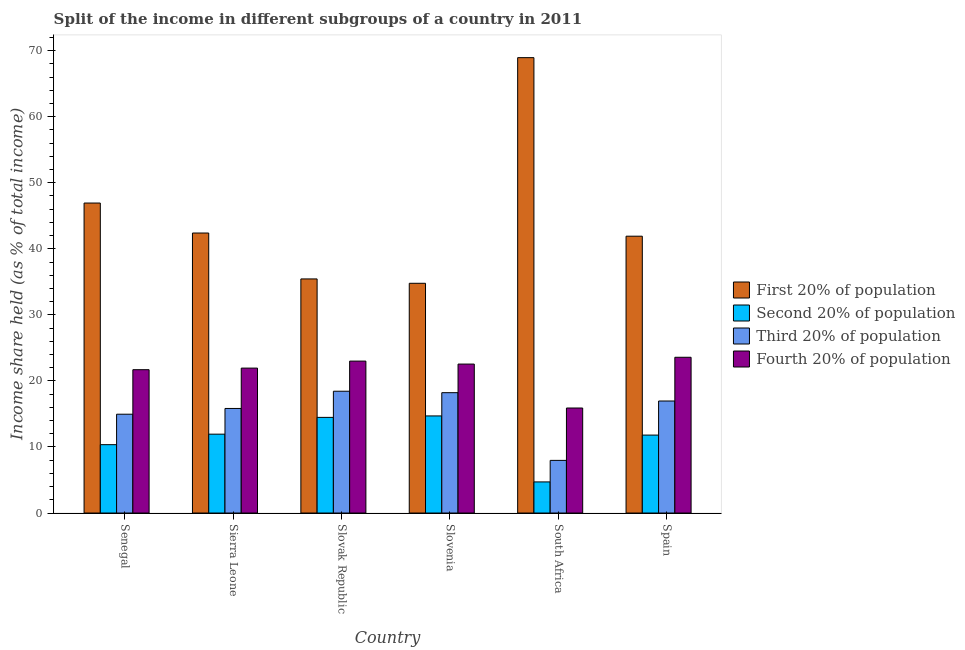How many different coloured bars are there?
Make the answer very short. 4. Are the number of bars per tick equal to the number of legend labels?
Your response must be concise. Yes. How many bars are there on the 3rd tick from the left?
Ensure brevity in your answer.  4. What is the label of the 3rd group of bars from the left?
Provide a succinct answer. Slovak Republic. In how many cases, is the number of bars for a given country not equal to the number of legend labels?
Make the answer very short. 0. What is the share of the income held by third 20% of the population in Senegal?
Your answer should be compact. 14.96. Across all countries, what is the maximum share of the income held by fourth 20% of the population?
Your answer should be very brief. 23.58. Across all countries, what is the minimum share of the income held by second 20% of the population?
Your response must be concise. 4.71. In which country was the share of the income held by second 20% of the population minimum?
Keep it short and to the point. South Africa. What is the total share of the income held by second 20% of the population in the graph?
Provide a short and direct response. 67.98. What is the difference between the share of the income held by first 20% of the population in Senegal and that in Sierra Leone?
Provide a succinct answer. 4.54. What is the difference between the share of the income held by first 20% of the population in Slovak Republic and the share of the income held by fourth 20% of the population in Slovenia?
Your answer should be very brief. 12.89. What is the average share of the income held by first 20% of the population per country?
Your response must be concise. 45.06. What is the difference between the share of the income held by first 20% of the population and share of the income held by fourth 20% of the population in Slovenia?
Provide a short and direct response. 12.23. What is the ratio of the share of the income held by fourth 20% of the population in Senegal to that in Slovenia?
Your answer should be very brief. 0.96. Is the share of the income held by first 20% of the population in Senegal less than that in Spain?
Make the answer very short. No. Is the difference between the share of the income held by second 20% of the population in Senegal and South Africa greater than the difference between the share of the income held by first 20% of the population in Senegal and South Africa?
Ensure brevity in your answer.  Yes. What is the difference between the highest and the second highest share of the income held by second 20% of the population?
Provide a succinct answer. 0.22. What is the difference between the highest and the lowest share of the income held by fourth 20% of the population?
Your response must be concise. 7.68. Is it the case that in every country, the sum of the share of the income held by third 20% of the population and share of the income held by second 20% of the population is greater than the sum of share of the income held by fourth 20% of the population and share of the income held by first 20% of the population?
Offer a terse response. No. What does the 4th bar from the left in Spain represents?
Your answer should be very brief. Fourth 20% of population. What does the 2nd bar from the right in Slovak Republic represents?
Keep it short and to the point. Third 20% of population. Is it the case that in every country, the sum of the share of the income held by first 20% of the population and share of the income held by second 20% of the population is greater than the share of the income held by third 20% of the population?
Ensure brevity in your answer.  Yes. What is the difference between two consecutive major ticks on the Y-axis?
Offer a very short reply. 10. Are the values on the major ticks of Y-axis written in scientific E-notation?
Keep it short and to the point. No. Does the graph contain any zero values?
Offer a very short reply. No. Does the graph contain grids?
Your response must be concise. No. Where does the legend appear in the graph?
Provide a succinct answer. Center right. How are the legend labels stacked?
Your answer should be very brief. Vertical. What is the title of the graph?
Make the answer very short. Split of the income in different subgroups of a country in 2011. Does "Sweden" appear as one of the legend labels in the graph?
Keep it short and to the point. No. What is the label or title of the X-axis?
Your answer should be very brief. Country. What is the label or title of the Y-axis?
Make the answer very short. Income share held (as % of total income). What is the Income share held (as % of total income) of First 20% of population in Senegal?
Offer a terse response. 46.93. What is the Income share held (as % of total income) of Second 20% of population in Senegal?
Offer a very short reply. 10.35. What is the Income share held (as % of total income) of Third 20% of population in Senegal?
Make the answer very short. 14.96. What is the Income share held (as % of total income) of Fourth 20% of population in Senegal?
Ensure brevity in your answer.  21.7. What is the Income share held (as % of total income) of First 20% of population in Sierra Leone?
Your response must be concise. 42.39. What is the Income share held (as % of total income) in Second 20% of population in Sierra Leone?
Give a very brief answer. 11.94. What is the Income share held (as % of total income) in Third 20% of population in Sierra Leone?
Your response must be concise. 15.83. What is the Income share held (as % of total income) of Fourth 20% of population in Sierra Leone?
Your answer should be very brief. 21.94. What is the Income share held (as % of total income) in First 20% of population in Slovak Republic?
Offer a very short reply. 35.44. What is the Income share held (as % of total income) in Second 20% of population in Slovak Republic?
Ensure brevity in your answer.  14.48. What is the Income share held (as % of total income) in Third 20% of population in Slovak Republic?
Your response must be concise. 18.44. What is the Income share held (as % of total income) of First 20% of population in Slovenia?
Offer a terse response. 34.78. What is the Income share held (as % of total income) in Second 20% of population in Slovenia?
Your answer should be very brief. 14.7. What is the Income share held (as % of total income) in Third 20% of population in Slovenia?
Your answer should be compact. 18.22. What is the Income share held (as % of total income) of Fourth 20% of population in Slovenia?
Keep it short and to the point. 22.55. What is the Income share held (as % of total income) of First 20% of population in South Africa?
Give a very brief answer. 68.94. What is the Income share held (as % of total income) of Second 20% of population in South Africa?
Provide a succinct answer. 4.71. What is the Income share held (as % of total income) of Third 20% of population in South Africa?
Give a very brief answer. 7.97. What is the Income share held (as % of total income) in Fourth 20% of population in South Africa?
Ensure brevity in your answer.  15.9. What is the Income share held (as % of total income) in First 20% of population in Spain?
Your answer should be very brief. 41.91. What is the Income share held (as % of total income) of Second 20% of population in Spain?
Offer a terse response. 11.8. What is the Income share held (as % of total income) of Third 20% of population in Spain?
Ensure brevity in your answer.  16.96. What is the Income share held (as % of total income) of Fourth 20% of population in Spain?
Your answer should be compact. 23.58. Across all countries, what is the maximum Income share held (as % of total income) of First 20% of population?
Provide a short and direct response. 68.94. Across all countries, what is the maximum Income share held (as % of total income) of Third 20% of population?
Provide a succinct answer. 18.44. Across all countries, what is the maximum Income share held (as % of total income) of Fourth 20% of population?
Make the answer very short. 23.58. Across all countries, what is the minimum Income share held (as % of total income) of First 20% of population?
Make the answer very short. 34.78. Across all countries, what is the minimum Income share held (as % of total income) in Second 20% of population?
Make the answer very short. 4.71. Across all countries, what is the minimum Income share held (as % of total income) in Third 20% of population?
Offer a very short reply. 7.97. Across all countries, what is the minimum Income share held (as % of total income) in Fourth 20% of population?
Provide a succinct answer. 15.9. What is the total Income share held (as % of total income) in First 20% of population in the graph?
Offer a very short reply. 270.39. What is the total Income share held (as % of total income) of Second 20% of population in the graph?
Offer a very short reply. 67.98. What is the total Income share held (as % of total income) in Third 20% of population in the graph?
Keep it short and to the point. 92.38. What is the total Income share held (as % of total income) in Fourth 20% of population in the graph?
Ensure brevity in your answer.  128.67. What is the difference between the Income share held (as % of total income) of First 20% of population in Senegal and that in Sierra Leone?
Give a very brief answer. 4.54. What is the difference between the Income share held (as % of total income) of Second 20% of population in Senegal and that in Sierra Leone?
Your answer should be very brief. -1.59. What is the difference between the Income share held (as % of total income) of Third 20% of population in Senegal and that in Sierra Leone?
Give a very brief answer. -0.87. What is the difference between the Income share held (as % of total income) in Fourth 20% of population in Senegal and that in Sierra Leone?
Provide a succinct answer. -0.24. What is the difference between the Income share held (as % of total income) in First 20% of population in Senegal and that in Slovak Republic?
Make the answer very short. 11.49. What is the difference between the Income share held (as % of total income) in Second 20% of population in Senegal and that in Slovak Republic?
Give a very brief answer. -4.13. What is the difference between the Income share held (as % of total income) in Third 20% of population in Senegal and that in Slovak Republic?
Your answer should be very brief. -3.48. What is the difference between the Income share held (as % of total income) in First 20% of population in Senegal and that in Slovenia?
Your answer should be very brief. 12.15. What is the difference between the Income share held (as % of total income) in Second 20% of population in Senegal and that in Slovenia?
Your answer should be very brief. -4.35. What is the difference between the Income share held (as % of total income) in Third 20% of population in Senegal and that in Slovenia?
Your answer should be compact. -3.26. What is the difference between the Income share held (as % of total income) of Fourth 20% of population in Senegal and that in Slovenia?
Provide a short and direct response. -0.85. What is the difference between the Income share held (as % of total income) of First 20% of population in Senegal and that in South Africa?
Your answer should be very brief. -22.01. What is the difference between the Income share held (as % of total income) of Second 20% of population in Senegal and that in South Africa?
Offer a very short reply. 5.64. What is the difference between the Income share held (as % of total income) in Third 20% of population in Senegal and that in South Africa?
Offer a terse response. 6.99. What is the difference between the Income share held (as % of total income) of First 20% of population in Senegal and that in Spain?
Your answer should be very brief. 5.02. What is the difference between the Income share held (as % of total income) of Second 20% of population in Senegal and that in Spain?
Your answer should be very brief. -1.45. What is the difference between the Income share held (as % of total income) in Fourth 20% of population in Senegal and that in Spain?
Ensure brevity in your answer.  -1.88. What is the difference between the Income share held (as % of total income) of First 20% of population in Sierra Leone and that in Slovak Republic?
Make the answer very short. 6.95. What is the difference between the Income share held (as % of total income) in Second 20% of population in Sierra Leone and that in Slovak Republic?
Your response must be concise. -2.54. What is the difference between the Income share held (as % of total income) in Third 20% of population in Sierra Leone and that in Slovak Republic?
Ensure brevity in your answer.  -2.61. What is the difference between the Income share held (as % of total income) of Fourth 20% of population in Sierra Leone and that in Slovak Republic?
Provide a short and direct response. -1.06. What is the difference between the Income share held (as % of total income) of First 20% of population in Sierra Leone and that in Slovenia?
Give a very brief answer. 7.61. What is the difference between the Income share held (as % of total income) of Second 20% of population in Sierra Leone and that in Slovenia?
Provide a short and direct response. -2.76. What is the difference between the Income share held (as % of total income) in Third 20% of population in Sierra Leone and that in Slovenia?
Offer a terse response. -2.39. What is the difference between the Income share held (as % of total income) in Fourth 20% of population in Sierra Leone and that in Slovenia?
Your answer should be compact. -0.61. What is the difference between the Income share held (as % of total income) in First 20% of population in Sierra Leone and that in South Africa?
Keep it short and to the point. -26.55. What is the difference between the Income share held (as % of total income) of Second 20% of population in Sierra Leone and that in South Africa?
Your answer should be compact. 7.23. What is the difference between the Income share held (as % of total income) in Third 20% of population in Sierra Leone and that in South Africa?
Give a very brief answer. 7.86. What is the difference between the Income share held (as % of total income) in Fourth 20% of population in Sierra Leone and that in South Africa?
Your response must be concise. 6.04. What is the difference between the Income share held (as % of total income) in First 20% of population in Sierra Leone and that in Spain?
Your response must be concise. 0.48. What is the difference between the Income share held (as % of total income) of Second 20% of population in Sierra Leone and that in Spain?
Offer a terse response. 0.14. What is the difference between the Income share held (as % of total income) in Third 20% of population in Sierra Leone and that in Spain?
Provide a short and direct response. -1.13. What is the difference between the Income share held (as % of total income) of Fourth 20% of population in Sierra Leone and that in Spain?
Offer a very short reply. -1.64. What is the difference between the Income share held (as % of total income) of First 20% of population in Slovak Republic and that in Slovenia?
Your answer should be compact. 0.66. What is the difference between the Income share held (as % of total income) of Second 20% of population in Slovak Republic and that in Slovenia?
Keep it short and to the point. -0.22. What is the difference between the Income share held (as % of total income) of Third 20% of population in Slovak Republic and that in Slovenia?
Provide a succinct answer. 0.22. What is the difference between the Income share held (as % of total income) of Fourth 20% of population in Slovak Republic and that in Slovenia?
Your response must be concise. 0.45. What is the difference between the Income share held (as % of total income) of First 20% of population in Slovak Republic and that in South Africa?
Keep it short and to the point. -33.5. What is the difference between the Income share held (as % of total income) in Second 20% of population in Slovak Republic and that in South Africa?
Provide a succinct answer. 9.77. What is the difference between the Income share held (as % of total income) in Third 20% of population in Slovak Republic and that in South Africa?
Provide a short and direct response. 10.47. What is the difference between the Income share held (as % of total income) in First 20% of population in Slovak Republic and that in Spain?
Your answer should be compact. -6.47. What is the difference between the Income share held (as % of total income) of Second 20% of population in Slovak Republic and that in Spain?
Provide a short and direct response. 2.68. What is the difference between the Income share held (as % of total income) in Third 20% of population in Slovak Republic and that in Spain?
Your answer should be compact. 1.48. What is the difference between the Income share held (as % of total income) of Fourth 20% of population in Slovak Republic and that in Spain?
Make the answer very short. -0.58. What is the difference between the Income share held (as % of total income) of First 20% of population in Slovenia and that in South Africa?
Ensure brevity in your answer.  -34.16. What is the difference between the Income share held (as % of total income) in Second 20% of population in Slovenia and that in South Africa?
Your answer should be very brief. 9.99. What is the difference between the Income share held (as % of total income) in Third 20% of population in Slovenia and that in South Africa?
Offer a terse response. 10.25. What is the difference between the Income share held (as % of total income) of Fourth 20% of population in Slovenia and that in South Africa?
Your answer should be very brief. 6.65. What is the difference between the Income share held (as % of total income) of First 20% of population in Slovenia and that in Spain?
Provide a succinct answer. -7.13. What is the difference between the Income share held (as % of total income) in Second 20% of population in Slovenia and that in Spain?
Keep it short and to the point. 2.9. What is the difference between the Income share held (as % of total income) in Third 20% of population in Slovenia and that in Spain?
Provide a succinct answer. 1.26. What is the difference between the Income share held (as % of total income) in Fourth 20% of population in Slovenia and that in Spain?
Your response must be concise. -1.03. What is the difference between the Income share held (as % of total income) of First 20% of population in South Africa and that in Spain?
Give a very brief answer. 27.03. What is the difference between the Income share held (as % of total income) of Second 20% of population in South Africa and that in Spain?
Your answer should be very brief. -7.09. What is the difference between the Income share held (as % of total income) in Third 20% of population in South Africa and that in Spain?
Ensure brevity in your answer.  -8.99. What is the difference between the Income share held (as % of total income) of Fourth 20% of population in South Africa and that in Spain?
Your response must be concise. -7.68. What is the difference between the Income share held (as % of total income) of First 20% of population in Senegal and the Income share held (as % of total income) of Second 20% of population in Sierra Leone?
Keep it short and to the point. 34.99. What is the difference between the Income share held (as % of total income) of First 20% of population in Senegal and the Income share held (as % of total income) of Third 20% of population in Sierra Leone?
Provide a short and direct response. 31.1. What is the difference between the Income share held (as % of total income) in First 20% of population in Senegal and the Income share held (as % of total income) in Fourth 20% of population in Sierra Leone?
Your answer should be very brief. 24.99. What is the difference between the Income share held (as % of total income) of Second 20% of population in Senegal and the Income share held (as % of total income) of Third 20% of population in Sierra Leone?
Offer a very short reply. -5.48. What is the difference between the Income share held (as % of total income) in Second 20% of population in Senegal and the Income share held (as % of total income) in Fourth 20% of population in Sierra Leone?
Your answer should be compact. -11.59. What is the difference between the Income share held (as % of total income) in Third 20% of population in Senegal and the Income share held (as % of total income) in Fourth 20% of population in Sierra Leone?
Give a very brief answer. -6.98. What is the difference between the Income share held (as % of total income) in First 20% of population in Senegal and the Income share held (as % of total income) in Second 20% of population in Slovak Republic?
Provide a succinct answer. 32.45. What is the difference between the Income share held (as % of total income) of First 20% of population in Senegal and the Income share held (as % of total income) of Third 20% of population in Slovak Republic?
Your answer should be very brief. 28.49. What is the difference between the Income share held (as % of total income) of First 20% of population in Senegal and the Income share held (as % of total income) of Fourth 20% of population in Slovak Republic?
Your answer should be very brief. 23.93. What is the difference between the Income share held (as % of total income) in Second 20% of population in Senegal and the Income share held (as % of total income) in Third 20% of population in Slovak Republic?
Your answer should be compact. -8.09. What is the difference between the Income share held (as % of total income) in Second 20% of population in Senegal and the Income share held (as % of total income) in Fourth 20% of population in Slovak Republic?
Offer a very short reply. -12.65. What is the difference between the Income share held (as % of total income) of Third 20% of population in Senegal and the Income share held (as % of total income) of Fourth 20% of population in Slovak Republic?
Your response must be concise. -8.04. What is the difference between the Income share held (as % of total income) of First 20% of population in Senegal and the Income share held (as % of total income) of Second 20% of population in Slovenia?
Your answer should be compact. 32.23. What is the difference between the Income share held (as % of total income) of First 20% of population in Senegal and the Income share held (as % of total income) of Third 20% of population in Slovenia?
Ensure brevity in your answer.  28.71. What is the difference between the Income share held (as % of total income) in First 20% of population in Senegal and the Income share held (as % of total income) in Fourth 20% of population in Slovenia?
Keep it short and to the point. 24.38. What is the difference between the Income share held (as % of total income) in Second 20% of population in Senegal and the Income share held (as % of total income) in Third 20% of population in Slovenia?
Your answer should be compact. -7.87. What is the difference between the Income share held (as % of total income) of Third 20% of population in Senegal and the Income share held (as % of total income) of Fourth 20% of population in Slovenia?
Keep it short and to the point. -7.59. What is the difference between the Income share held (as % of total income) of First 20% of population in Senegal and the Income share held (as % of total income) of Second 20% of population in South Africa?
Ensure brevity in your answer.  42.22. What is the difference between the Income share held (as % of total income) in First 20% of population in Senegal and the Income share held (as % of total income) in Third 20% of population in South Africa?
Provide a short and direct response. 38.96. What is the difference between the Income share held (as % of total income) of First 20% of population in Senegal and the Income share held (as % of total income) of Fourth 20% of population in South Africa?
Make the answer very short. 31.03. What is the difference between the Income share held (as % of total income) of Second 20% of population in Senegal and the Income share held (as % of total income) of Third 20% of population in South Africa?
Make the answer very short. 2.38. What is the difference between the Income share held (as % of total income) in Second 20% of population in Senegal and the Income share held (as % of total income) in Fourth 20% of population in South Africa?
Provide a succinct answer. -5.55. What is the difference between the Income share held (as % of total income) in Third 20% of population in Senegal and the Income share held (as % of total income) in Fourth 20% of population in South Africa?
Offer a very short reply. -0.94. What is the difference between the Income share held (as % of total income) in First 20% of population in Senegal and the Income share held (as % of total income) in Second 20% of population in Spain?
Offer a very short reply. 35.13. What is the difference between the Income share held (as % of total income) in First 20% of population in Senegal and the Income share held (as % of total income) in Third 20% of population in Spain?
Give a very brief answer. 29.97. What is the difference between the Income share held (as % of total income) in First 20% of population in Senegal and the Income share held (as % of total income) in Fourth 20% of population in Spain?
Your answer should be compact. 23.35. What is the difference between the Income share held (as % of total income) in Second 20% of population in Senegal and the Income share held (as % of total income) in Third 20% of population in Spain?
Make the answer very short. -6.61. What is the difference between the Income share held (as % of total income) in Second 20% of population in Senegal and the Income share held (as % of total income) in Fourth 20% of population in Spain?
Offer a very short reply. -13.23. What is the difference between the Income share held (as % of total income) of Third 20% of population in Senegal and the Income share held (as % of total income) of Fourth 20% of population in Spain?
Keep it short and to the point. -8.62. What is the difference between the Income share held (as % of total income) in First 20% of population in Sierra Leone and the Income share held (as % of total income) in Second 20% of population in Slovak Republic?
Your response must be concise. 27.91. What is the difference between the Income share held (as % of total income) in First 20% of population in Sierra Leone and the Income share held (as % of total income) in Third 20% of population in Slovak Republic?
Provide a succinct answer. 23.95. What is the difference between the Income share held (as % of total income) in First 20% of population in Sierra Leone and the Income share held (as % of total income) in Fourth 20% of population in Slovak Republic?
Keep it short and to the point. 19.39. What is the difference between the Income share held (as % of total income) in Second 20% of population in Sierra Leone and the Income share held (as % of total income) in Fourth 20% of population in Slovak Republic?
Provide a succinct answer. -11.06. What is the difference between the Income share held (as % of total income) in Third 20% of population in Sierra Leone and the Income share held (as % of total income) in Fourth 20% of population in Slovak Republic?
Your response must be concise. -7.17. What is the difference between the Income share held (as % of total income) of First 20% of population in Sierra Leone and the Income share held (as % of total income) of Second 20% of population in Slovenia?
Give a very brief answer. 27.69. What is the difference between the Income share held (as % of total income) of First 20% of population in Sierra Leone and the Income share held (as % of total income) of Third 20% of population in Slovenia?
Provide a short and direct response. 24.17. What is the difference between the Income share held (as % of total income) of First 20% of population in Sierra Leone and the Income share held (as % of total income) of Fourth 20% of population in Slovenia?
Provide a short and direct response. 19.84. What is the difference between the Income share held (as % of total income) of Second 20% of population in Sierra Leone and the Income share held (as % of total income) of Third 20% of population in Slovenia?
Give a very brief answer. -6.28. What is the difference between the Income share held (as % of total income) of Second 20% of population in Sierra Leone and the Income share held (as % of total income) of Fourth 20% of population in Slovenia?
Ensure brevity in your answer.  -10.61. What is the difference between the Income share held (as % of total income) in Third 20% of population in Sierra Leone and the Income share held (as % of total income) in Fourth 20% of population in Slovenia?
Give a very brief answer. -6.72. What is the difference between the Income share held (as % of total income) in First 20% of population in Sierra Leone and the Income share held (as % of total income) in Second 20% of population in South Africa?
Your response must be concise. 37.68. What is the difference between the Income share held (as % of total income) of First 20% of population in Sierra Leone and the Income share held (as % of total income) of Third 20% of population in South Africa?
Make the answer very short. 34.42. What is the difference between the Income share held (as % of total income) of First 20% of population in Sierra Leone and the Income share held (as % of total income) of Fourth 20% of population in South Africa?
Your answer should be very brief. 26.49. What is the difference between the Income share held (as % of total income) of Second 20% of population in Sierra Leone and the Income share held (as % of total income) of Third 20% of population in South Africa?
Your answer should be very brief. 3.97. What is the difference between the Income share held (as % of total income) of Second 20% of population in Sierra Leone and the Income share held (as % of total income) of Fourth 20% of population in South Africa?
Your answer should be very brief. -3.96. What is the difference between the Income share held (as % of total income) in Third 20% of population in Sierra Leone and the Income share held (as % of total income) in Fourth 20% of population in South Africa?
Your response must be concise. -0.07. What is the difference between the Income share held (as % of total income) of First 20% of population in Sierra Leone and the Income share held (as % of total income) of Second 20% of population in Spain?
Make the answer very short. 30.59. What is the difference between the Income share held (as % of total income) in First 20% of population in Sierra Leone and the Income share held (as % of total income) in Third 20% of population in Spain?
Give a very brief answer. 25.43. What is the difference between the Income share held (as % of total income) in First 20% of population in Sierra Leone and the Income share held (as % of total income) in Fourth 20% of population in Spain?
Keep it short and to the point. 18.81. What is the difference between the Income share held (as % of total income) in Second 20% of population in Sierra Leone and the Income share held (as % of total income) in Third 20% of population in Spain?
Your response must be concise. -5.02. What is the difference between the Income share held (as % of total income) in Second 20% of population in Sierra Leone and the Income share held (as % of total income) in Fourth 20% of population in Spain?
Your answer should be very brief. -11.64. What is the difference between the Income share held (as % of total income) of Third 20% of population in Sierra Leone and the Income share held (as % of total income) of Fourth 20% of population in Spain?
Make the answer very short. -7.75. What is the difference between the Income share held (as % of total income) of First 20% of population in Slovak Republic and the Income share held (as % of total income) of Second 20% of population in Slovenia?
Give a very brief answer. 20.74. What is the difference between the Income share held (as % of total income) of First 20% of population in Slovak Republic and the Income share held (as % of total income) of Third 20% of population in Slovenia?
Your answer should be compact. 17.22. What is the difference between the Income share held (as % of total income) of First 20% of population in Slovak Republic and the Income share held (as % of total income) of Fourth 20% of population in Slovenia?
Offer a terse response. 12.89. What is the difference between the Income share held (as % of total income) of Second 20% of population in Slovak Republic and the Income share held (as % of total income) of Third 20% of population in Slovenia?
Provide a succinct answer. -3.74. What is the difference between the Income share held (as % of total income) in Second 20% of population in Slovak Republic and the Income share held (as % of total income) in Fourth 20% of population in Slovenia?
Your response must be concise. -8.07. What is the difference between the Income share held (as % of total income) of Third 20% of population in Slovak Republic and the Income share held (as % of total income) of Fourth 20% of population in Slovenia?
Offer a terse response. -4.11. What is the difference between the Income share held (as % of total income) in First 20% of population in Slovak Republic and the Income share held (as % of total income) in Second 20% of population in South Africa?
Ensure brevity in your answer.  30.73. What is the difference between the Income share held (as % of total income) in First 20% of population in Slovak Republic and the Income share held (as % of total income) in Third 20% of population in South Africa?
Your answer should be compact. 27.47. What is the difference between the Income share held (as % of total income) of First 20% of population in Slovak Republic and the Income share held (as % of total income) of Fourth 20% of population in South Africa?
Provide a short and direct response. 19.54. What is the difference between the Income share held (as % of total income) in Second 20% of population in Slovak Republic and the Income share held (as % of total income) in Third 20% of population in South Africa?
Provide a succinct answer. 6.51. What is the difference between the Income share held (as % of total income) in Second 20% of population in Slovak Republic and the Income share held (as % of total income) in Fourth 20% of population in South Africa?
Provide a succinct answer. -1.42. What is the difference between the Income share held (as % of total income) of Third 20% of population in Slovak Republic and the Income share held (as % of total income) of Fourth 20% of population in South Africa?
Your answer should be very brief. 2.54. What is the difference between the Income share held (as % of total income) of First 20% of population in Slovak Republic and the Income share held (as % of total income) of Second 20% of population in Spain?
Keep it short and to the point. 23.64. What is the difference between the Income share held (as % of total income) of First 20% of population in Slovak Republic and the Income share held (as % of total income) of Third 20% of population in Spain?
Provide a short and direct response. 18.48. What is the difference between the Income share held (as % of total income) of First 20% of population in Slovak Republic and the Income share held (as % of total income) of Fourth 20% of population in Spain?
Your response must be concise. 11.86. What is the difference between the Income share held (as % of total income) of Second 20% of population in Slovak Republic and the Income share held (as % of total income) of Third 20% of population in Spain?
Your response must be concise. -2.48. What is the difference between the Income share held (as % of total income) of Second 20% of population in Slovak Republic and the Income share held (as % of total income) of Fourth 20% of population in Spain?
Provide a short and direct response. -9.1. What is the difference between the Income share held (as % of total income) of Third 20% of population in Slovak Republic and the Income share held (as % of total income) of Fourth 20% of population in Spain?
Offer a very short reply. -5.14. What is the difference between the Income share held (as % of total income) of First 20% of population in Slovenia and the Income share held (as % of total income) of Second 20% of population in South Africa?
Keep it short and to the point. 30.07. What is the difference between the Income share held (as % of total income) of First 20% of population in Slovenia and the Income share held (as % of total income) of Third 20% of population in South Africa?
Give a very brief answer. 26.81. What is the difference between the Income share held (as % of total income) of First 20% of population in Slovenia and the Income share held (as % of total income) of Fourth 20% of population in South Africa?
Your answer should be compact. 18.88. What is the difference between the Income share held (as % of total income) in Second 20% of population in Slovenia and the Income share held (as % of total income) in Third 20% of population in South Africa?
Your response must be concise. 6.73. What is the difference between the Income share held (as % of total income) of Third 20% of population in Slovenia and the Income share held (as % of total income) of Fourth 20% of population in South Africa?
Your answer should be compact. 2.32. What is the difference between the Income share held (as % of total income) in First 20% of population in Slovenia and the Income share held (as % of total income) in Second 20% of population in Spain?
Your response must be concise. 22.98. What is the difference between the Income share held (as % of total income) of First 20% of population in Slovenia and the Income share held (as % of total income) of Third 20% of population in Spain?
Your answer should be very brief. 17.82. What is the difference between the Income share held (as % of total income) in Second 20% of population in Slovenia and the Income share held (as % of total income) in Third 20% of population in Spain?
Ensure brevity in your answer.  -2.26. What is the difference between the Income share held (as % of total income) of Second 20% of population in Slovenia and the Income share held (as % of total income) of Fourth 20% of population in Spain?
Ensure brevity in your answer.  -8.88. What is the difference between the Income share held (as % of total income) in Third 20% of population in Slovenia and the Income share held (as % of total income) in Fourth 20% of population in Spain?
Ensure brevity in your answer.  -5.36. What is the difference between the Income share held (as % of total income) of First 20% of population in South Africa and the Income share held (as % of total income) of Second 20% of population in Spain?
Your answer should be compact. 57.14. What is the difference between the Income share held (as % of total income) in First 20% of population in South Africa and the Income share held (as % of total income) in Third 20% of population in Spain?
Provide a short and direct response. 51.98. What is the difference between the Income share held (as % of total income) in First 20% of population in South Africa and the Income share held (as % of total income) in Fourth 20% of population in Spain?
Your response must be concise. 45.36. What is the difference between the Income share held (as % of total income) of Second 20% of population in South Africa and the Income share held (as % of total income) of Third 20% of population in Spain?
Your answer should be very brief. -12.25. What is the difference between the Income share held (as % of total income) of Second 20% of population in South Africa and the Income share held (as % of total income) of Fourth 20% of population in Spain?
Your answer should be compact. -18.87. What is the difference between the Income share held (as % of total income) of Third 20% of population in South Africa and the Income share held (as % of total income) of Fourth 20% of population in Spain?
Give a very brief answer. -15.61. What is the average Income share held (as % of total income) in First 20% of population per country?
Make the answer very short. 45.06. What is the average Income share held (as % of total income) in Second 20% of population per country?
Provide a succinct answer. 11.33. What is the average Income share held (as % of total income) in Third 20% of population per country?
Offer a terse response. 15.4. What is the average Income share held (as % of total income) of Fourth 20% of population per country?
Ensure brevity in your answer.  21.45. What is the difference between the Income share held (as % of total income) in First 20% of population and Income share held (as % of total income) in Second 20% of population in Senegal?
Provide a succinct answer. 36.58. What is the difference between the Income share held (as % of total income) of First 20% of population and Income share held (as % of total income) of Third 20% of population in Senegal?
Provide a succinct answer. 31.97. What is the difference between the Income share held (as % of total income) in First 20% of population and Income share held (as % of total income) in Fourth 20% of population in Senegal?
Keep it short and to the point. 25.23. What is the difference between the Income share held (as % of total income) of Second 20% of population and Income share held (as % of total income) of Third 20% of population in Senegal?
Offer a very short reply. -4.61. What is the difference between the Income share held (as % of total income) in Second 20% of population and Income share held (as % of total income) in Fourth 20% of population in Senegal?
Provide a succinct answer. -11.35. What is the difference between the Income share held (as % of total income) of Third 20% of population and Income share held (as % of total income) of Fourth 20% of population in Senegal?
Offer a very short reply. -6.74. What is the difference between the Income share held (as % of total income) of First 20% of population and Income share held (as % of total income) of Second 20% of population in Sierra Leone?
Keep it short and to the point. 30.45. What is the difference between the Income share held (as % of total income) of First 20% of population and Income share held (as % of total income) of Third 20% of population in Sierra Leone?
Your answer should be compact. 26.56. What is the difference between the Income share held (as % of total income) of First 20% of population and Income share held (as % of total income) of Fourth 20% of population in Sierra Leone?
Your answer should be very brief. 20.45. What is the difference between the Income share held (as % of total income) of Second 20% of population and Income share held (as % of total income) of Third 20% of population in Sierra Leone?
Your answer should be compact. -3.89. What is the difference between the Income share held (as % of total income) of Second 20% of population and Income share held (as % of total income) of Fourth 20% of population in Sierra Leone?
Your answer should be very brief. -10. What is the difference between the Income share held (as % of total income) of Third 20% of population and Income share held (as % of total income) of Fourth 20% of population in Sierra Leone?
Provide a succinct answer. -6.11. What is the difference between the Income share held (as % of total income) in First 20% of population and Income share held (as % of total income) in Second 20% of population in Slovak Republic?
Keep it short and to the point. 20.96. What is the difference between the Income share held (as % of total income) in First 20% of population and Income share held (as % of total income) in Third 20% of population in Slovak Republic?
Your answer should be very brief. 17. What is the difference between the Income share held (as % of total income) of First 20% of population and Income share held (as % of total income) of Fourth 20% of population in Slovak Republic?
Provide a short and direct response. 12.44. What is the difference between the Income share held (as % of total income) of Second 20% of population and Income share held (as % of total income) of Third 20% of population in Slovak Republic?
Provide a short and direct response. -3.96. What is the difference between the Income share held (as % of total income) of Second 20% of population and Income share held (as % of total income) of Fourth 20% of population in Slovak Republic?
Keep it short and to the point. -8.52. What is the difference between the Income share held (as % of total income) in Third 20% of population and Income share held (as % of total income) in Fourth 20% of population in Slovak Republic?
Provide a short and direct response. -4.56. What is the difference between the Income share held (as % of total income) in First 20% of population and Income share held (as % of total income) in Second 20% of population in Slovenia?
Ensure brevity in your answer.  20.08. What is the difference between the Income share held (as % of total income) of First 20% of population and Income share held (as % of total income) of Third 20% of population in Slovenia?
Provide a succinct answer. 16.56. What is the difference between the Income share held (as % of total income) of First 20% of population and Income share held (as % of total income) of Fourth 20% of population in Slovenia?
Your answer should be very brief. 12.23. What is the difference between the Income share held (as % of total income) in Second 20% of population and Income share held (as % of total income) in Third 20% of population in Slovenia?
Provide a short and direct response. -3.52. What is the difference between the Income share held (as % of total income) of Second 20% of population and Income share held (as % of total income) of Fourth 20% of population in Slovenia?
Make the answer very short. -7.85. What is the difference between the Income share held (as % of total income) in Third 20% of population and Income share held (as % of total income) in Fourth 20% of population in Slovenia?
Offer a very short reply. -4.33. What is the difference between the Income share held (as % of total income) of First 20% of population and Income share held (as % of total income) of Second 20% of population in South Africa?
Keep it short and to the point. 64.23. What is the difference between the Income share held (as % of total income) of First 20% of population and Income share held (as % of total income) of Third 20% of population in South Africa?
Your answer should be very brief. 60.97. What is the difference between the Income share held (as % of total income) of First 20% of population and Income share held (as % of total income) of Fourth 20% of population in South Africa?
Your answer should be compact. 53.04. What is the difference between the Income share held (as % of total income) of Second 20% of population and Income share held (as % of total income) of Third 20% of population in South Africa?
Your response must be concise. -3.26. What is the difference between the Income share held (as % of total income) in Second 20% of population and Income share held (as % of total income) in Fourth 20% of population in South Africa?
Make the answer very short. -11.19. What is the difference between the Income share held (as % of total income) in Third 20% of population and Income share held (as % of total income) in Fourth 20% of population in South Africa?
Provide a succinct answer. -7.93. What is the difference between the Income share held (as % of total income) of First 20% of population and Income share held (as % of total income) of Second 20% of population in Spain?
Provide a short and direct response. 30.11. What is the difference between the Income share held (as % of total income) in First 20% of population and Income share held (as % of total income) in Third 20% of population in Spain?
Keep it short and to the point. 24.95. What is the difference between the Income share held (as % of total income) in First 20% of population and Income share held (as % of total income) in Fourth 20% of population in Spain?
Ensure brevity in your answer.  18.33. What is the difference between the Income share held (as % of total income) in Second 20% of population and Income share held (as % of total income) in Third 20% of population in Spain?
Your answer should be compact. -5.16. What is the difference between the Income share held (as % of total income) in Second 20% of population and Income share held (as % of total income) in Fourth 20% of population in Spain?
Your answer should be compact. -11.78. What is the difference between the Income share held (as % of total income) of Third 20% of population and Income share held (as % of total income) of Fourth 20% of population in Spain?
Offer a terse response. -6.62. What is the ratio of the Income share held (as % of total income) of First 20% of population in Senegal to that in Sierra Leone?
Your answer should be compact. 1.11. What is the ratio of the Income share held (as % of total income) in Second 20% of population in Senegal to that in Sierra Leone?
Offer a terse response. 0.87. What is the ratio of the Income share held (as % of total income) of Third 20% of population in Senegal to that in Sierra Leone?
Offer a terse response. 0.94. What is the ratio of the Income share held (as % of total income) of Fourth 20% of population in Senegal to that in Sierra Leone?
Your answer should be compact. 0.99. What is the ratio of the Income share held (as % of total income) in First 20% of population in Senegal to that in Slovak Republic?
Make the answer very short. 1.32. What is the ratio of the Income share held (as % of total income) in Second 20% of population in Senegal to that in Slovak Republic?
Make the answer very short. 0.71. What is the ratio of the Income share held (as % of total income) of Third 20% of population in Senegal to that in Slovak Republic?
Give a very brief answer. 0.81. What is the ratio of the Income share held (as % of total income) of Fourth 20% of population in Senegal to that in Slovak Republic?
Offer a terse response. 0.94. What is the ratio of the Income share held (as % of total income) in First 20% of population in Senegal to that in Slovenia?
Provide a short and direct response. 1.35. What is the ratio of the Income share held (as % of total income) in Second 20% of population in Senegal to that in Slovenia?
Your answer should be compact. 0.7. What is the ratio of the Income share held (as % of total income) in Third 20% of population in Senegal to that in Slovenia?
Your response must be concise. 0.82. What is the ratio of the Income share held (as % of total income) in Fourth 20% of population in Senegal to that in Slovenia?
Keep it short and to the point. 0.96. What is the ratio of the Income share held (as % of total income) of First 20% of population in Senegal to that in South Africa?
Keep it short and to the point. 0.68. What is the ratio of the Income share held (as % of total income) in Second 20% of population in Senegal to that in South Africa?
Your answer should be compact. 2.2. What is the ratio of the Income share held (as % of total income) in Third 20% of population in Senegal to that in South Africa?
Your answer should be very brief. 1.88. What is the ratio of the Income share held (as % of total income) in Fourth 20% of population in Senegal to that in South Africa?
Your response must be concise. 1.36. What is the ratio of the Income share held (as % of total income) in First 20% of population in Senegal to that in Spain?
Your response must be concise. 1.12. What is the ratio of the Income share held (as % of total income) of Second 20% of population in Senegal to that in Spain?
Provide a short and direct response. 0.88. What is the ratio of the Income share held (as % of total income) of Third 20% of population in Senegal to that in Spain?
Make the answer very short. 0.88. What is the ratio of the Income share held (as % of total income) of Fourth 20% of population in Senegal to that in Spain?
Your answer should be compact. 0.92. What is the ratio of the Income share held (as % of total income) in First 20% of population in Sierra Leone to that in Slovak Republic?
Offer a very short reply. 1.2. What is the ratio of the Income share held (as % of total income) in Second 20% of population in Sierra Leone to that in Slovak Republic?
Make the answer very short. 0.82. What is the ratio of the Income share held (as % of total income) of Third 20% of population in Sierra Leone to that in Slovak Republic?
Your answer should be compact. 0.86. What is the ratio of the Income share held (as % of total income) of Fourth 20% of population in Sierra Leone to that in Slovak Republic?
Your response must be concise. 0.95. What is the ratio of the Income share held (as % of total income) in First 20% of population in Sierra Leone to that in Slovenia?
Give a very brief answer. 1.22. What is the ratio of the Income share held (as % of total income) in Second 20% of population in Sierra Leone to that in Slovenia?
Your answer should be compact. 0.81. What is the ratio of the Income share held (as % of total income) of Third 20% of population in Sierra Leone to that in Slovenia?
Ensure brevity in your answer.  0.87. What is the ratio of the Income share held (as % of total income) in Fourth 20% of population in Sierra Leone to that in Slovenia?
Provide a succinct answer. 0.97. What is the ratio of the Income share held (as % of total income) in First 20% of population in Sierra Leone to that in South Africa?
Give a very brief answer. 0.61. What is the ratio of the Income share held (as % of total income) in Second 20% of population in Sierra Leone to that in South Africa?
Ensure brevity in your answer.  2.54. What is the ratio of the Income share held (as % of total income) in Third 20% of population in Sierra Leone to that in South Africa?
Give a very brief answer. 1.99. What is the ratio of the Income share held (as % of total income) in Fourth 20% of population in Sierra Leone to that in South Africa?
Your answer should be very brief. 1.38. What is the ratio of the Income share held (as % of total income) of First 20% of population in Sierra Leone to that in Spain?
Your response must be concise. 1.01. What is the ratio of the Income share held (as % of total income) of Second 20% of population in Sierra Leone to that in Spain?
Your answer should be compact. 1.01. What is the ratio of the Income share held (as % of total income) of Third 20% of population in Sierra Leone to that in Spain?
Provide a succinct answer. 0.93. What is the ratio of the Income share held (as % of total income) in Fourth 20% of population in Sierra Leone to that in Spain?
Offer a terse response. 0.93. What is the ratio of the Income share held (as % of total income) in Second 20% of population in Slovak Republic to that in Slovenia?
Provide a short and direct response. 0.98. What is the ratio of the Income share held (as % of total income) of Third 20% of population in Slovak Republic to that in Slovenia?
Offer a terse response. 1.01. What is the ratio of the Income share held (as % of total income) in Fourth 20% of population in Slovak Republic to that in Slovenia?
Provide a succinct answer. 1.02. What is the ratio of the Income share held (as % of total income) in First 20% of population in Slovak Republic to that in South Africa?
Your answer should be very brief. 0.51. What is the ratio of the Income share held (as % of total income) of Second 20% of population in Slovak Republic to that in South Africa?
Offer a terse response. 3.07. What is the ratio of the Income share held (as % of total income) in Third 20% of population in Slovak Republic to that in South Africa?
Make the answer very short. 2.31. What is the ratio of the Income share held (as % of total income) of Fourth 20% of population in Slovak Republic to that in South Africa?
Give a very brief answer. 1.45. What is the ratio of the Income share held (as % of total income) of First 20% of population in Slovak Republic to that in Spain?
Offer a very short reply. 0.85. What is the ratio of the Income share held (as % of total income) in Second 20% of population in Slovak Republic to that in Spain?
Make the answer very short. 1.23. What is the ratio of the Income share held (as % of total income) of Third 20% of population in Slovak Republic to that in Spain?
Your answer should be compact. 1.09. What is the ratio of the Income share held (as % of total income) in Fourth 20% of population in Slovak Republic to that in Spain?
Provide a short and direct response. 0.98. What is the ratio of the Income share held (as % of total income) in First 20% of population in Slovenia to that in South Africa?
Offer a terse response. 0.5. What is the ratio of the Income share held (as % of total income) in Second 20% of population in Slovenia to that in South Africa?
Give a very brief answer. 3.12. What is the ratio of the Income share held (as % of total income) in Third 20% of population in Slovenia to that in South Africa?
Ensure brevity in your answer.  2.29. What is the ratio of the Income share held (as % of total income) in Fourth 20% of population in Slovenia to that in South Africa?
Give a very brief answer. 1.42. What is the ratio of the Income share held (as % of total income) of First 20% of population in Slovenia to that in Spain?
Give a very brief answer. 0.83. What is the ratio of the Income share held (as % of total income) in Second 20% of population in Slovenia to that in Spain?
Provide a succinct answer. 1.25. What is the ratio of the Income share held (as % of total income) in Third 20% of population in Slovenia to that in Spain?
Your response must be concise. 1.07. What is the ratio of the Income share held (as % of total income) in Fourth 20% of population in Slovenia to that in Spain?
Offer a very short reply. 0.96. What is the ratio of the Income share held (as % of total income) in First 20% of population in South Africa to that in Spain?
Provide a short and direct response. 1.65. What is the ratio of the Income share held (as % of total income) in Second 20% of population in South Africa to that in Spain?
Ensure brevity in your answer.  0.4. What is the ratio of the Income share held (as % of total income) of Third 20% of population in South Africa to that in Spain?
Give a very brief answer. 0.47. What is the ratio of the Income share held (as % of total income) of Fourth 20% of population in South Africa to that in Spain?
Your answer should be very brief. 0.67. What is the difference between the highest and the second highest Income share held (as % of total income) in First 20% of population?
Your answer should be compact. 22.01. What is the difference between the highest and the second highest Income share held (as % of total income) of Second 20% of population?
Make the answer very short. 0.22. What is the difference between the highest and the second highest Income share held (as % of total income) of Third 20% of population?
Your answer should be compact. 0.22. What is the difference between the highest and the second highest Income share held (as % of total income) in Fourth 20% of population?
Your response must be concise. 0.58. What is the difference between the highest and the lowest Income share held (as % of total income) of First 20% of population?
Offer a terse response. 34.16. What is the difference between the highest and the lowest Income share held (as % of total income) in Second 20% of population?
Make the answer very short. 9.99. What is the difference between the highest and the lowest Income share held (as % of total income) of Third 20% of population?
Keep it short and to the point. 10.47. What is the difference between the highest and the lowest Income share held (as % of total income) of Fourth 20% of population?
Offer a terse response. 7.68. 